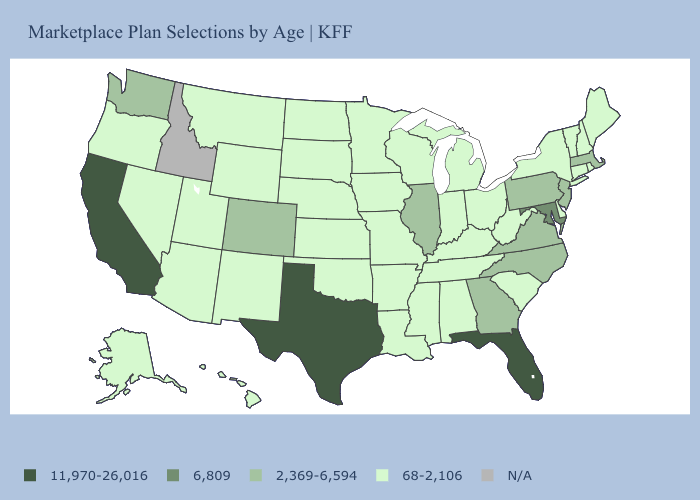Name the states that have a value in the range 11,970-26,016?
Answer briefly. California, Florida, Texas. What is the highest value in the South ?
Write a very short answer. 11,970-26,016. Name the states that have a value in the range 2,369-6,594?
Be succinct. Colorado, Georgia, Illinois, Massachusetts, New Jersey, North Carolina, Pennsylvania, Virginia, Washington. What is the value of New Hampshire?
Concise answer only. 68-2,106. What is the highest value in the West ?
Answer briefly. 11,970-26,016. What is the value of Kansas?
Give a very brief answer. 68-2,106. What is the value of Maryland?
Quick response, please. 6,809. Does Nevada have the highest value in the West?
Quick response, please. No. What is the value of Illinois?
Short answer required. 2,369-6,594. How many symbols are there in the legend?
Give a very brief answer. 5. Which states have the highest value in the USA?
Short answer required. California, Florida, Texas. Which states hav the highest value in the MidWest?
Short answer required. Illinois. Does the first symbol in the legend represent the smallest category?
Give a very brief answer. No. Name the states that have a value in the range 6,809?
Give a very brief answer. Maryland. Name the states that have a value in the range 2,369-6,594?
Short answer required. Colorado, Georgia, Illinois, Massachusetts, New Jersey, North Carolina, Pennsylvania, Virginia, Washington. 